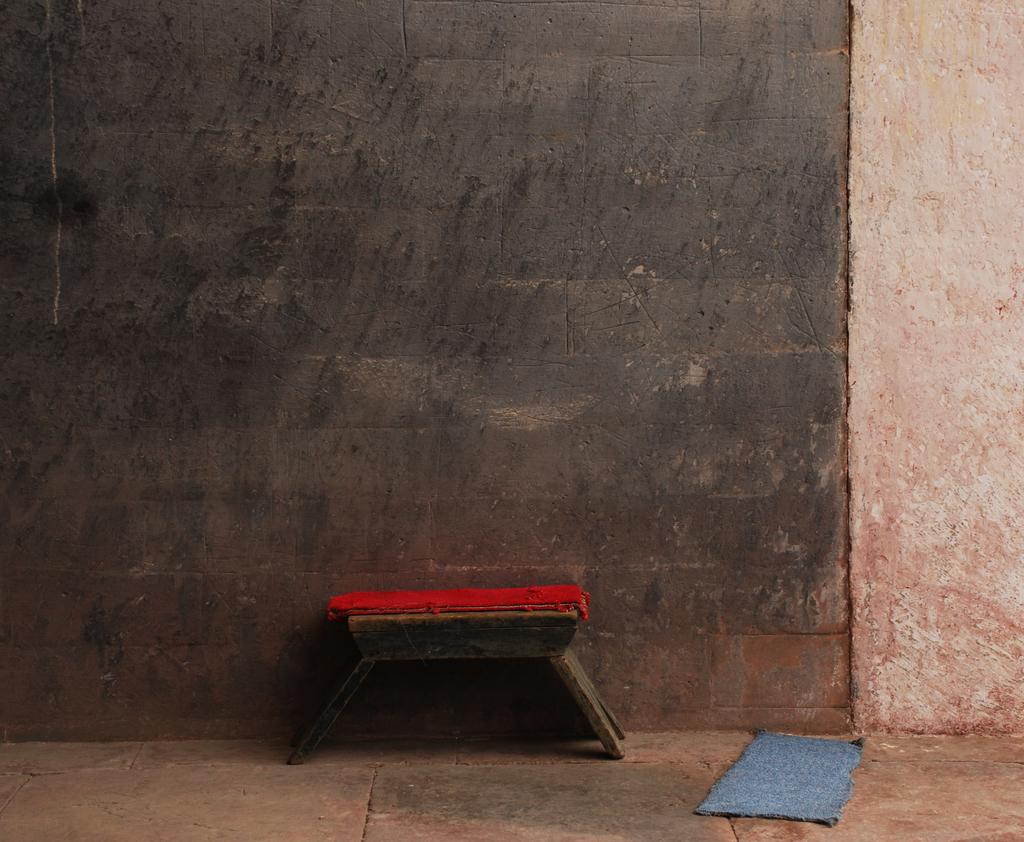What can be seen in the background of the image? There is a wall in the background of the image. What is on the floor in the image? There is a mat on the floor in the image. What type of furniture is present in the image? There is a small wooden table in the image. Where is the table located in relation to the wall? The table is near the wall. What color is the object on the table? There is a red object on the table. How many grains of rice are visible on the mat in the image? There is no rice visible on the mat in the image. What type of locket is hanging from the red object on the table? There is no locket present in the image. 